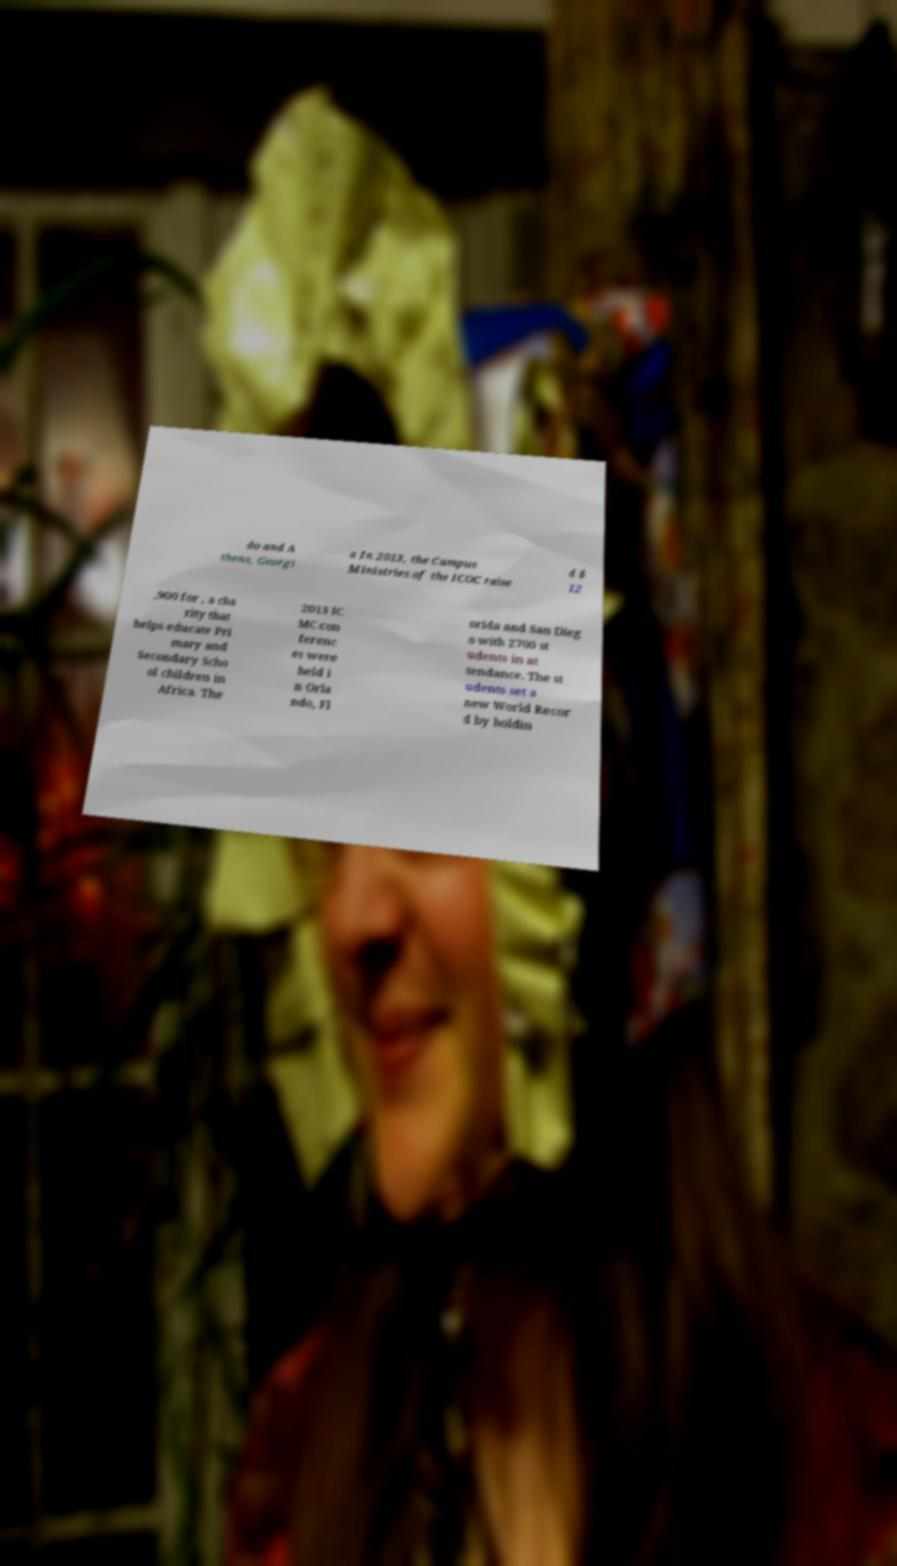For documentation purposes, I need the text within this image transcribed. Could you provide that? do and A thens, Georgi a In 2013, the Campus Ministries of the ICOC raise d $ 12 ,900 for , a cha rity that helps educate Pri mary and Secondary Scho ol children in Africa. The 2013 IC MC con ferenc es were held i n Orla ndo, Fl orida and San Dieg o with 2700 st udents in at tendance. The st udents set a new World Recor d by holdin 